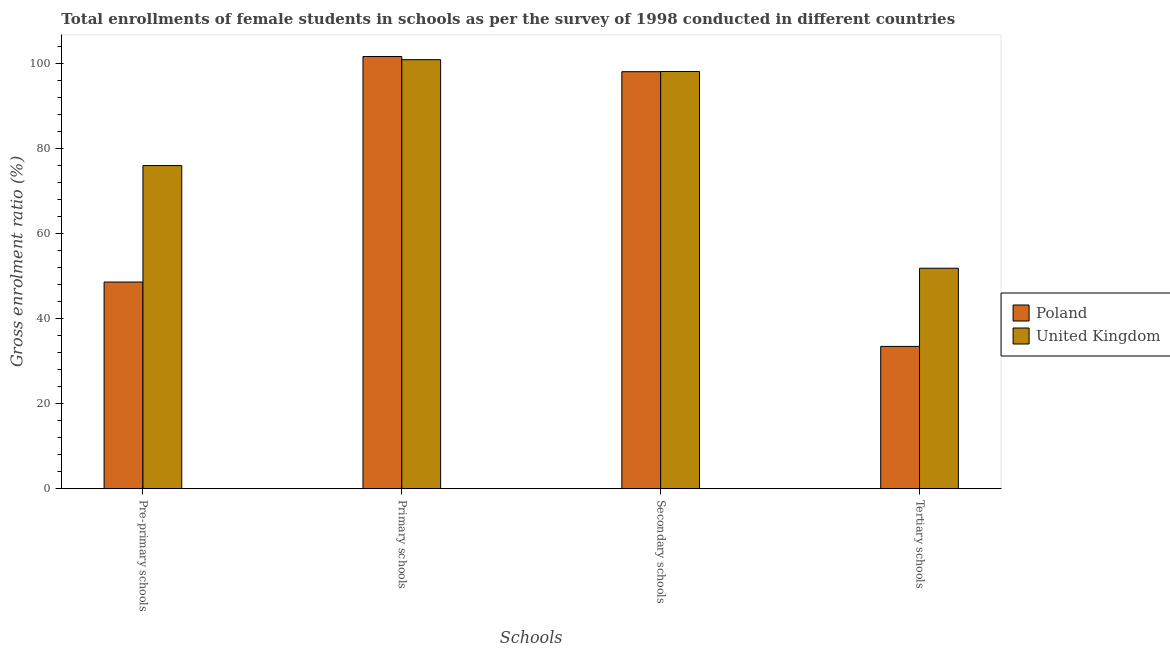Are the number of bars per tick equal to the number of legend labels?
Make the answer very short. Yes. How many bars are there on the 2nd tick from the right?
Offer a terse response. 2. What is the label of the 3rd group of bars from the left?
Provide a short and direct response. Secondary schools. What is the gross enrolment ratio(female) in tertiary schools in United Kingdom?
Provide a short and direct response. 51.87. Across all countries, what is the maximum gross enrolment ratio(female) in tertiary schools?
Ensure brevity in your answer.  51.87. Across all countries, what is the minimum gross enrolment ratio(female) in pre-primary schools?
Provide a succinct answer. 48.62. What is the total gross enrolment ratio(female) in pre-primary schools in the graph?
Provide a short and direct response. 124.64. What is the difference between the gross enrolment ratio(female) in tertiary schools in United Kingdom and that in Poland?
Offer a terse response. 18.39. What is the difference between the gross enrolment ratio(female) in tertiary schools in Poland and the gross enrolment ratio(female) in pre-primary schools in United Kingdom?
Ensure brevity in your answer.  -42.55. What is the average gross enrolment ratio(female) in secondary schools per country?
Keep it short and to the point. 98.13. What is the difference between the gross enrolment ratio(female) in pre-primary schools and gross enrolment ratio(female) in tertiary schools in Poland?
Ensure brevity in your answer.  15.14. What is the ratio of the gross enrolment ratio(female) in primary schools in Poland to that in United Kingdom?
Give a very brief answer. 1.01. Is the gross enrolment ratio(female) in secondary schools in United Kingdom less than that in Poland?
Offer a very short reply. No. Is the difference between the gross enrolment ratio(female) in pre-primary schools in Poland and United Kingdom greater than the difference between the gross enrolment ratio(female) in secondary schools in Poland and United Kingdom?
Keep it short and to the point. No. What is the difference between the highest and the second highest gross enrolment ratio(female) in secondary schools?
Your answer should be compact. 0.04. What is the difference between the highest and the lowest gross enrolment ratio(female) in primary schools?
Provide a short and direct response. 0.75. In how many countries, is the gross enrolment ratio(female) in primary schools greater than the average gross enrolment ratio(female) in primary schools taken over all countries?
Keep it short and to the point. 1. Are all the bars in the graph horizontal?
Your answer should be compact. No. What is the difference between two consecutive major ticks on the Y-axis?
Offer a very short reply. 20. Are the values on the major ticks of Y-axis written in scientific E-notation?
Offer a terse response. No. Does the graph contain any zero values?
Your answer should be very brief. No. Does the graph contain grids?
Provide a succinct answer. No. Where does the legend appear in the graph?
Your response must be concise. Center right. What is the title of the graph?
Make the answer very short. Total enrollments of female students in schools as per the survey of 1998 conducted in different countries. What is the label or title of the X-axis?
Keep it short and to the point. Schools. What is the Gross enrolment ratio (%) in Poland in Pre-primary schools?
Provide a succinct answer. 48.62. What is the Gross enrolment ratio (%) in United Kingdom in Pre-primary schools?
Provide a short and direct response. 76.02. What is the Gross enrolment ratio (%) of Poland in Primary schools?
Give a very brief answer. 101.69. What is the Gross enrolment ratio (%) of United Kingdom in Primary schools?
Make the answer very short. 100.93. What is the Gross enrolment ratio (%) of Poland in Secondary schools?
Your response must be concise. 98.11. What is the Gross enrolment ratio (%) of United Kingdom in Secondary schools?
Your answer should be compact. 98.15. What is the Gross enrolment ratio (%) of Poland in Tertiary schools?
Your answer should be compact. 33.48. What is the Gross enrolment ratio (%) in United Kingdom in Tertiary schools?
Your answer should be very brief. 51.87. Across all Schools, what is the maximum Gross enrolment ratio (%) of Poland?
Your response must be concise. 101.69. Across all Schools, what is the maximum Gross enrolment ratio (%) in United Kingdom?
Your answer should be compact. 100.93. Across all Schools, what is the minimum Gross enrolment ratio (%) of Poland?
Offer a terse response. 33.48. Across all Schools, what is the minimum Gross enrolment ratio (%) of United Kingdom?
Your answer should be very brief. 51.87. What is the total Gross enrolment ratio (%) in Poland in the graph?
Offer a very short reply. 281.89. What is the total Gross enrolment ratio (%) of United Kingdom in the graph?
Provide a short and direct response. 326.97. What is the difference between the Gross enrolment ratio (%) in Poland in Pre-primary schools and that in Primary schools?
Give a very brief answer. -53.07. What is the difference between the Gross enrolment ratio (%) of United Kingdom in Pre-primary schools and that in Primary schools?
Offer a terse response. -24.91. What is the difference between the Gross enrolment ratio (%) of Poland in Pre-primary schools and that in Secondary schools?
Provide a short and direct response. -49.49. What is the difference between the Gross enrolment ratio (%) in United Kingdom in Pre-primary schools and that in Secondary schools?
Provide a short and direct response. -22.13. What is the difference between the Gross enrolment ratio (%) of Poland in Pre-primary schools and that in Tertiary schools?
Give a very brief answer. 15.14. What is the difference between the Gross enrolment ratio (%) in United Kingdom in Pre-primary schools and that in Tertiary schools?
Your answer should be very brief. 24.15. What is the difference between the Gross enrolment ratio (%) of Poland in Primary schools and that in Secondary schools?
Provide a succinct answer. 3.58. What is the difference between the Gross enrolment ratio (%) of United Kingdom in Primary schools and that in Secondary schools?
Give a very brief answer. 2.79. What is the difference between the Gross enrolment ratio (%) of Poland in Primary schools and that in Tertiary schools?
Give a very brief answer. 68.21. What is the difference between the Gross enrolment ratio (%) of United Kingdom in Primary schools and that in Tertiary schools?
Your answer should be very brief. 49.06. What is the difference between the Gross enrolment ratio (%) in Poland in Secondary schools and that in Tertiary schools?
Your answer should be compact. 64.63. What is the difference between the Gross enrolment ratio (%) in United Kingdom in Secondary schools and that in Tertiary schools?
Offer a terse response. 46.28. What is the difference between the Gross enrolment ratio (%) in Poland in Pre-primary schools and the Gross enrolment ratio (%) in United Kingdom in Primary schools?
Your response must be concise. -52.32. What is the difference between the Gross enrolment ratio (%) in Poland in Pre-primary schools and the Gross enrolment ratio (%) in United Kingdom in Secondary schools?
Provide a succinct answer. -49.53. What is the difference between the Gross enrolment ratio (%) of Poland in Pre-primary schools and the Gross enrolment ratio (%) of United Kingdom in Tertiary schools?
Your answer should be compact. -3.25. What is the difference between the Gross enrolment ratio (%) of Poland in Primary schools and the Gross enrolment ratio (%) of United Kingdom in Secondary schools?
Your response must be concise. 3.54. What is the difference between the Gross enrolment ratio (%) in Poland in Primary schools and the Gross enrolment ratio (%) in United Kingdom in Tertiary schools?
Your answer should be compact. 49.82. What is the difference between the Gross enrolment ratio (%) in Poland in Secondary schools and the Gross enrolment ratio (%) in United Kingdom in Tertiary schools?
Your response must be concise. 46.24. What is the average Gross enrolment ratio (%) of Poland per Schools?
Give a very brief answer. 70.47. What is the average Gross enrolment ratio (%) in United Kingdom per Schools?
Give a very brief answer. 81.74. What is the difference between the Gross enrolment ratio (%) of Poland and Gross enrolment ratio (%) of United Kingdom in Pre-primary schools?
Give a very brief answer. -27.41. What is the difference between the Gross enrolment ratio (%) of Poland and Gross enrolment ratio (%) of United Kingdom in Primary schools?
Your answer should be very brief. 0.75. What is the difference between the Gross enrolment ratio (%) of Poland and Gross enrolment ratio (%) of United Kingdom in Secondary schools?
Give a very brief answer. -0.04. What is the difference between the Gross enrolment ratio (%) of Poland and Gross enrolment ratio (%) of United Kingdom in Tertiary schools?
Offer a terse response. -18.39. What is the ratio of the Gross enrolment ratio (%) of Poland in Pre-primary schools to that in Primary schools?
Your answer should be compact. 0.48. What is the ratio of the Gross enrolment ratio (%) in United Kingdom in Pre-primary schools to that in Primary schools?
Your answer should be very brief. 0.75. What is the ratio of the Gross enrolment ratio (%) in Poland in Pre-primary schools to that in Secondary schools?
Give a very brief answer. 0.5. What is the ratio of the Gross enrolment ratio (%) of United Kingdom in Pre-primary schools to that in Secondary schools?
Make the answer very short. 0.77. What is the ratio of the Gross enrolment ratio (%) of Poland in Pre-primary schools to that in Tertiary schools?
Offer a terse response. 1.45. What is the ratio of the Gross enrolment ratio (%) of United Kingdom in Pre-primary schools to that in Tertiary schools?
Provide a short and direct response. 1.47. What is the ratio of the Gross enrolment ratio (%) of Poland in Primary schools to that in Secondary schools?
Keep it short and to the point. 1.04. What is the ratio of the Gross enrolment ratio (%) in United Kingdom in Primary schools to that in Secondary schools?
Your answer should be very brief. 1.03. What is the ratio of the Gross enrolment ratio (%) in Poland in Primary schools to that in Tertiary schools?
Your answer should be compact. 3.04. What is the ratio of the Gross enrolment ratio (%) of United Kingdom in Primary schools to that in Tertiary schools?
Offer a very short reply. 1.95. What is the ratio of the Gross enrolment ratio (%) in Poland in Secondary schools to that in Tertiary schools?
Offer a very short reply. 2.93. What is the ratio of the Gross enrolment ratio (%) of United Kingdom in Secondary schools to that in Tertiary schools?
Make the answer very short. 1.89. What is the difference between the highest and the second highest Gross enrolment ratio (%) in Poland?
Provide a short and direct response. 3.58. What is the difference between the highest and the second highest Gross enrolment ratio (%) in United Kingdom?
Ensure brevity in your answer.  2.79. What is the difference between the highest and the lowest Gross enrolment ratio (%) in Poland?
Offer a terse response. 68.21. What is the difference between the highest and the lowest Gross enrolment ratio (%) of United Kingdom?
Ensure brevity in your answer.  49.06. 